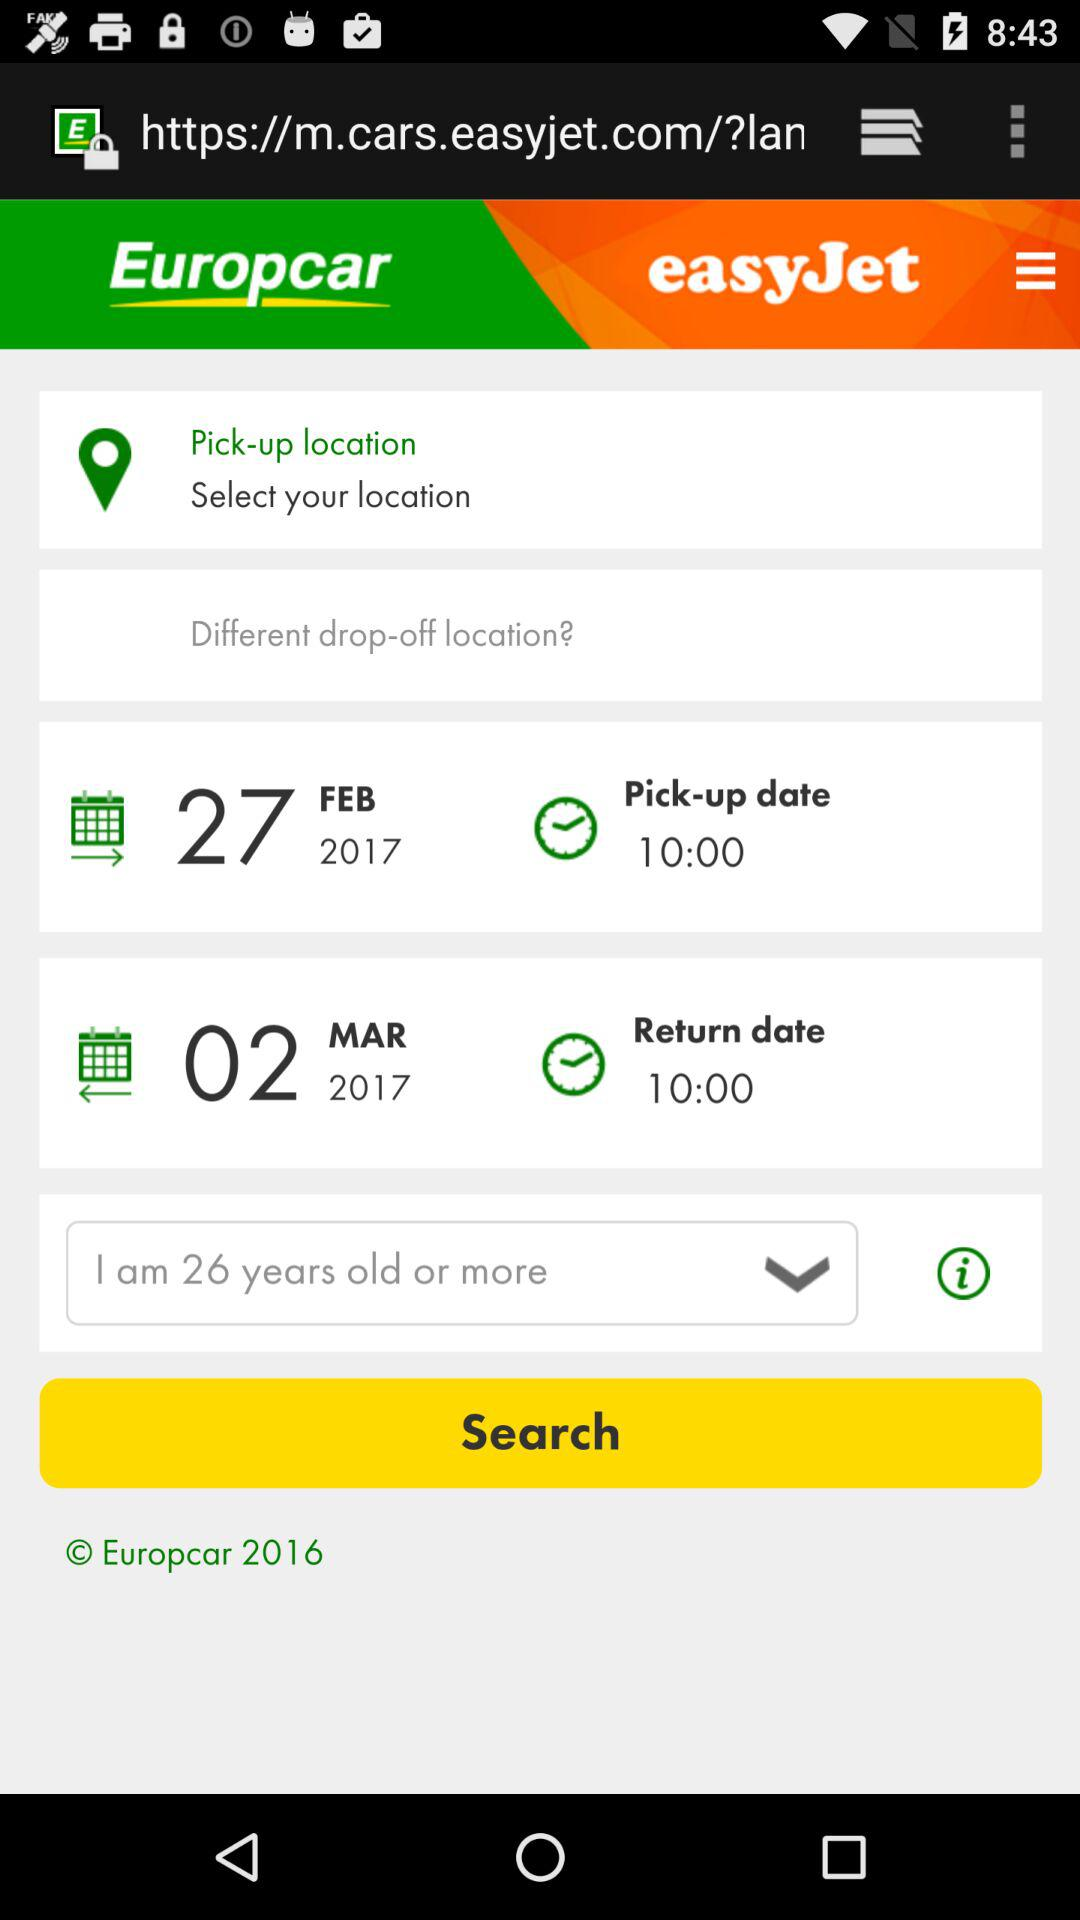What's the scheduled pick-up date and time? The scheduled pick-up date and time is February 27, 2017 at 10:00. 